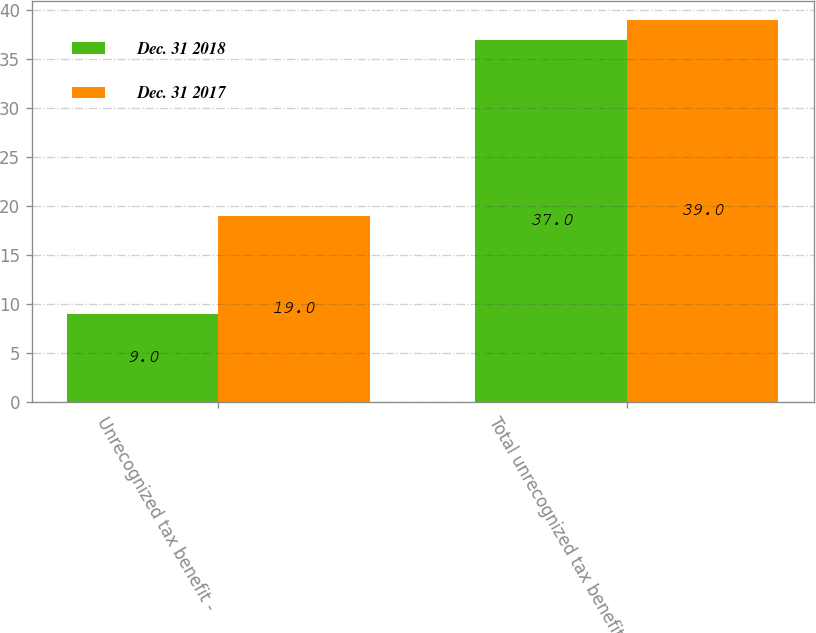Convert chart. <chart><loc_0><loc_0><loc_500><loc_500><stacked_bar_chart><ecel><fcel>Unrecognized tax benefit -<fcel>Total unrecognized tax benefit<nl><fcel>Dec. 31 2018<fcel>9<fcel>37<nl><fcel>Dec. 31 2017<fcel>19<fcel>39<nl></chart> 